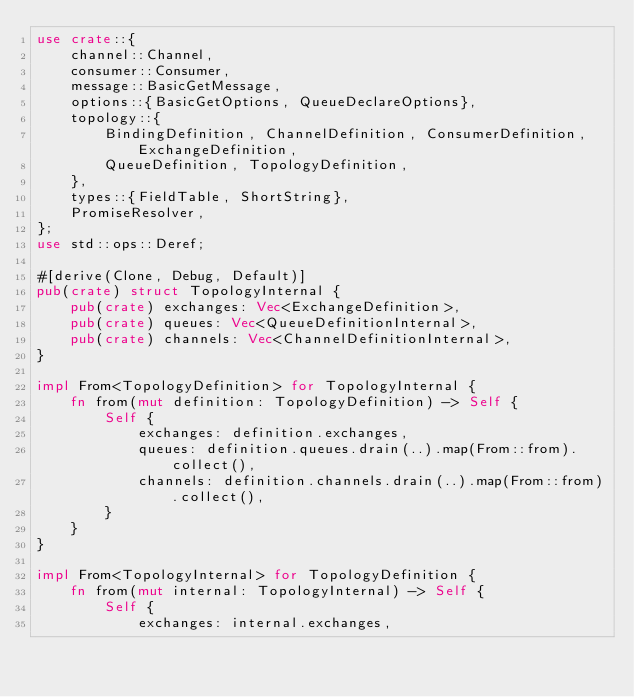<code> <loc_0><loc_0><loc_500><loc_500><_Rust_>use crate::{
    channel::Channel,
    consumer::Consumer,
    message::BasicGetMessage,
    options::{BasicGetOptions, QueueDeclareOptions},
    topology::{
        BindingDefinition, ChannelDefinition, ConsumerDefinition, ExchangeDefinition,
        QueueDefinition, TopologyDefinition,
    },
    types::{FieldTable, ShortString},
    PromiseResolver,
};
use std::ops::Deref;

#[derive(Clone, Debug, Default)]
pub(crate) struct TopologyInternal {
    pub(crate) exchanges: Vec<ExchangeDefinition>,
    pub(crate) queues: Vec<QueueDefinitionInternal>,
    pub(crate) channels: Vec<ChannelDefinitionInternal>,
}

impl From<TopologyDefinition> for TopologyInternal {
    fn from(mut definition: TopologyDefinition) -> Self {
        Self {
            exchanges: definition.exchanges,
            queues: definition.queues.drain(..).map(From::from).collect(),
            channels: definition.channels.drain(..).map(From::from).collect(),
        }
    }
}

impl From<TopologyInternal> for TopologyDefinition {
    fn from(mut internal: TopologyInternal) -> Self {
        Self {
            exchanges: internal.exchanges,</code> 